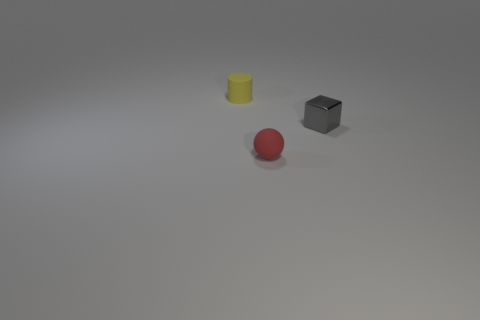Add 1 small yellow cylinders. How many objects exist? 4 Subtract all cylinders. How many objects are left? 2 Add 2 big gray matte things. How many big gray matte things exist? 2 Subtract 0 blue balls. How many objects are left? 3 Subtract all cylinders. Subtract all spheres. How many objects are left? 1 Add 1 tiny red rubber balls. How many tiny red rubber balls are left? 2 